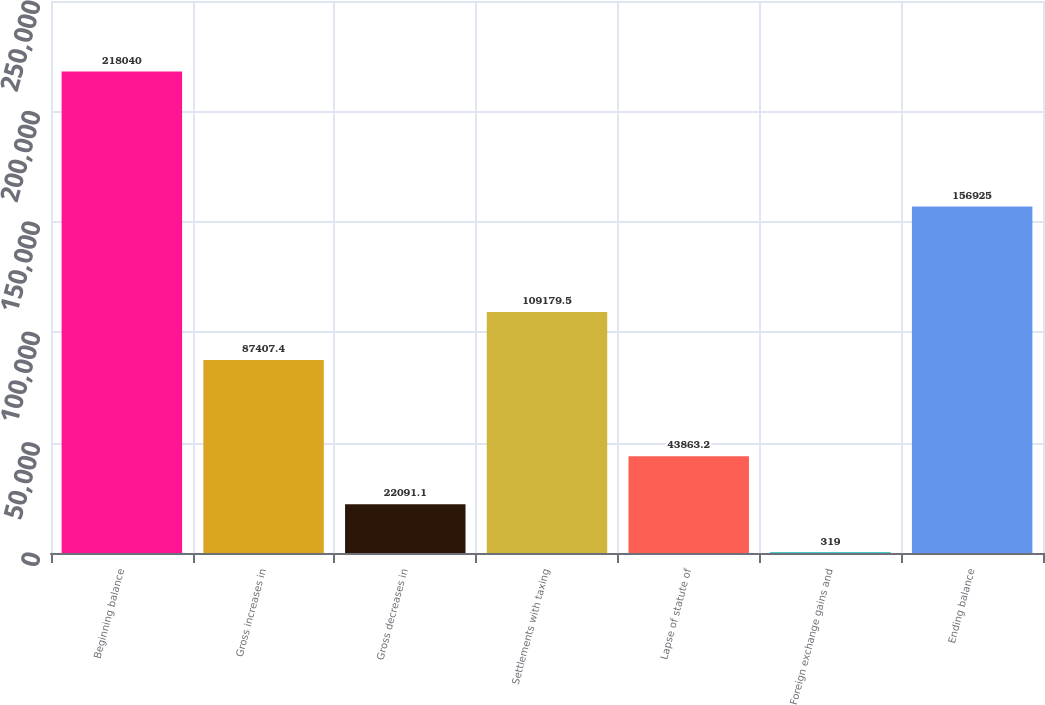Convert chart. <chart><loc_0><loc_0><loc_500><loc_500><bar_chart><fcel>Beginning balance<fcel>Gross increases in<fcel>Gross decreases in<fcel>Settlements with taxing<fcel>Lapse of statute of<fcel>Foreign exchange gains and<fcel>Ending balance<nl><fcel>218040<fcel>87407.4<fcel>22091.1<fcel>109180<fcel>43863.2<fcel>319<fcel>156925<nl></chart> 